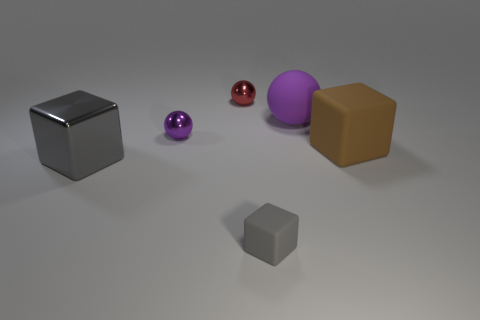Add 2 large blue matte objects. How many objects exist? 8 Subtract 0 purple cylinders. How many objects are left? 6 Subtract all big cyan metallic cylinders. Subtract all shiny blocks. How many objects are left? 5 Add 2 shiny cubes. How many shiny cubes are left? 3 Add 3 yellow matte blocks. How many yellow matte blocks exist? 3 